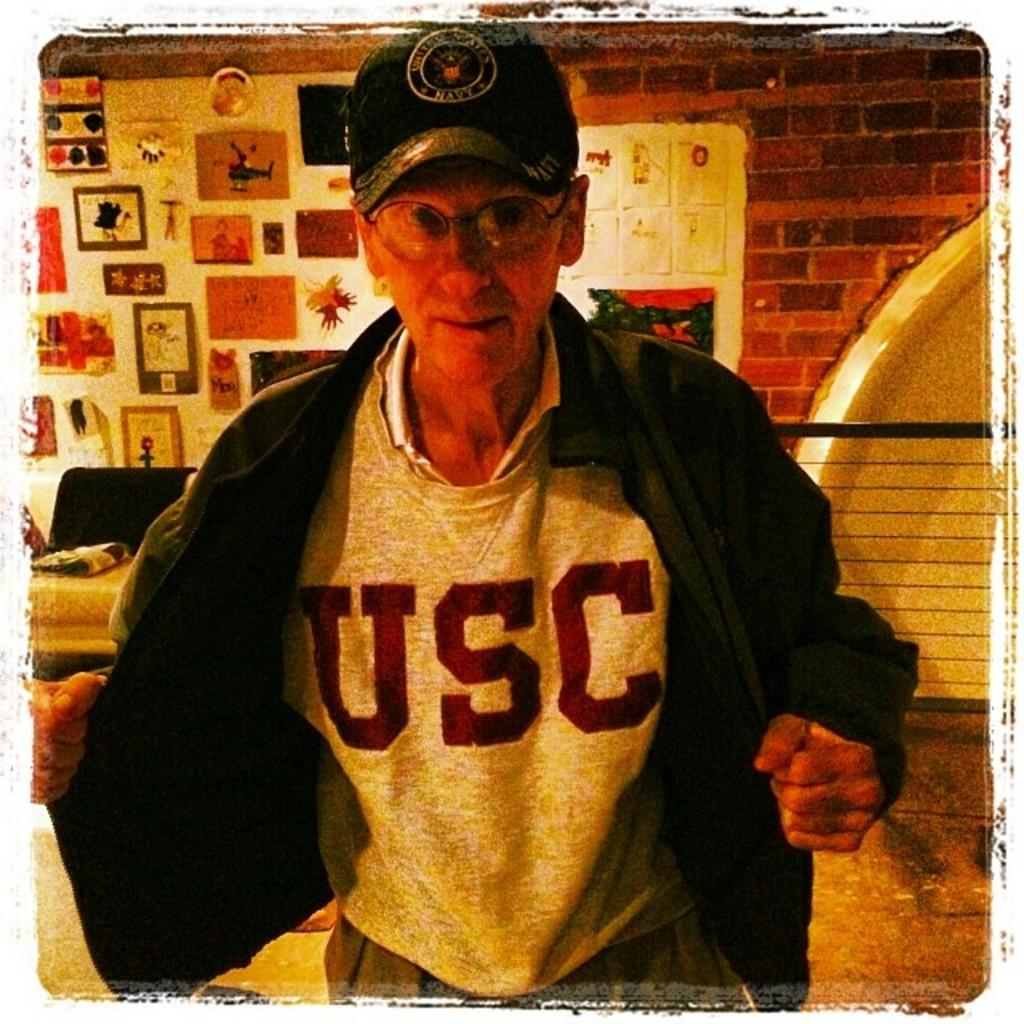Provide a one-sentence caption for the provided image. An elderly man opens his jacket to show off his USC t-shirt. 